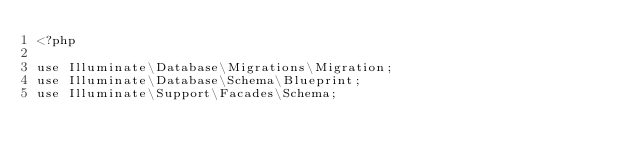<code> <loc_0><loc_0><loc_500><loc_500><_PHP_><?php

use Illuminate\Database\Migrations\Migration;
use Illuminate\Database\Schema\Blueprint;
use Illuminate\Support\Facades\Schema;
</code> 